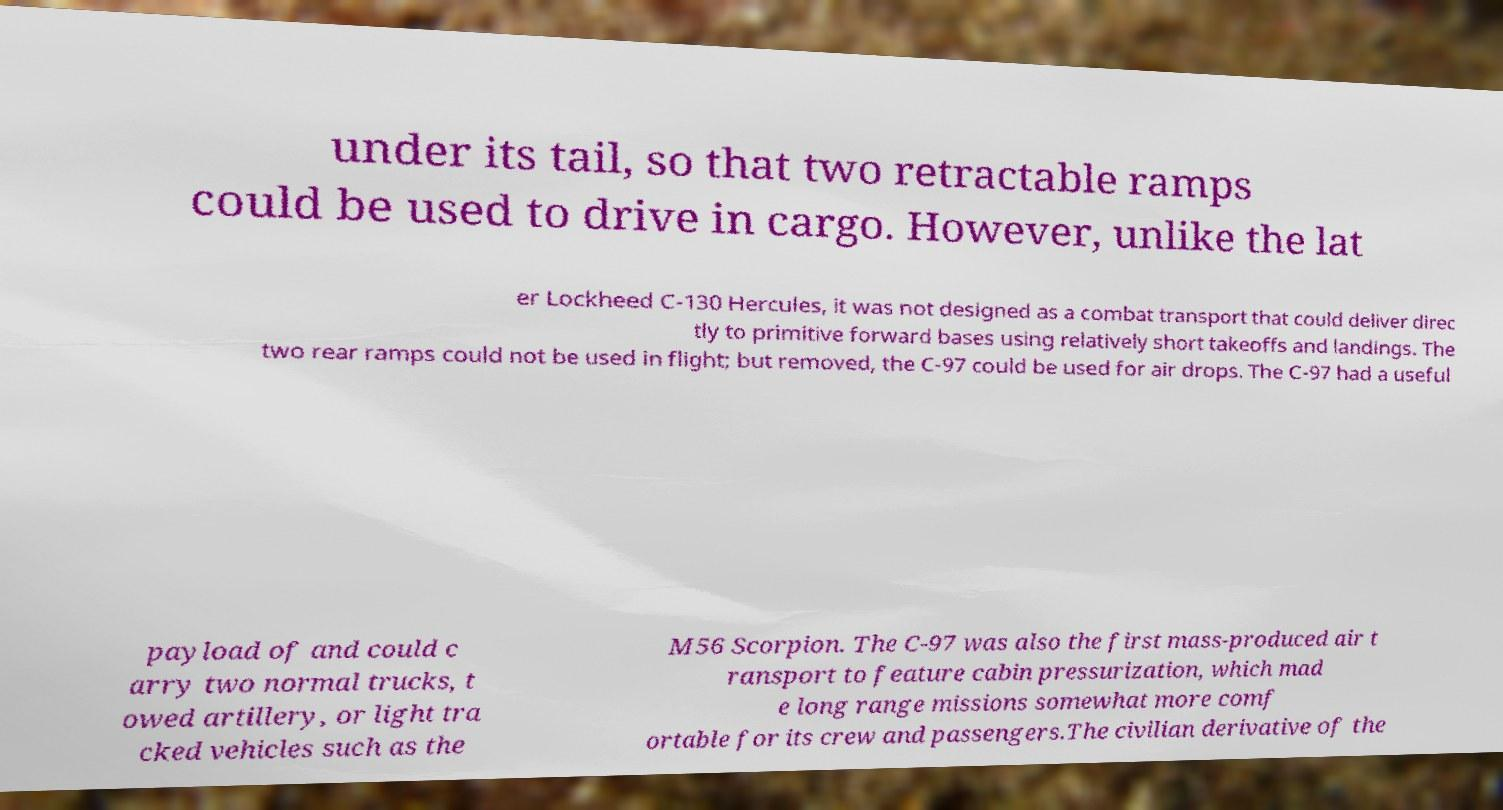Please read and relay the text visible in this image. What does it say? under its tail, so that two retractable ramps could be used to drive in cargo. However, unlike the lat er Lockheed C-130 Hercules, it was not designed as a combat transport that could deliver direc tly to primitive forward bases using relatively short takeoffs and landings. The two rear ramps could not be used in flight; but removed, the C-97 could be used for air drops. The C-97 had a useful payload of and could c arry two normal trucks, t owed artillery, or light tra cked vehicles such as the M56 Scorpion. The C-97 was also the first mass-produced air t ransport to feature cabin pressurization, which mad e long range missions somewhat more comf ortable for its crew and passengers.The civilian derivative of the 